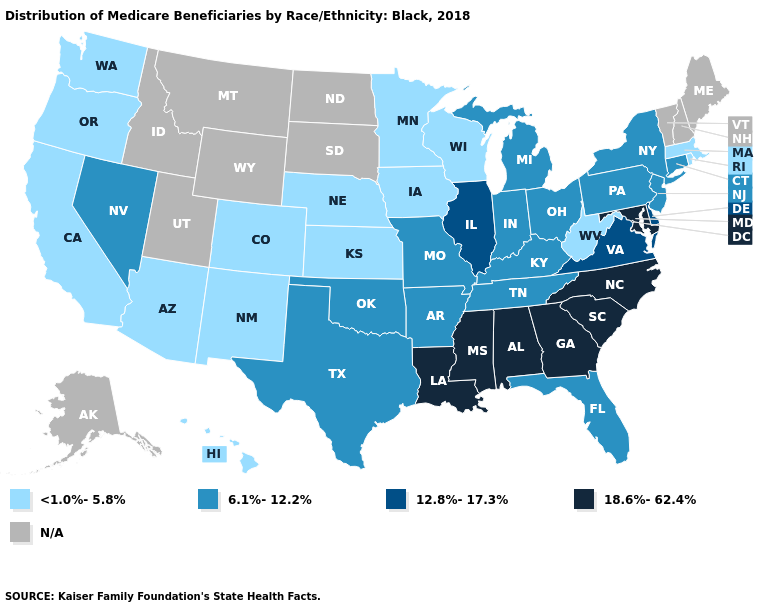Name the states that have a value in the range 6.1%-12.2%?
Keep it brief. Arkansas, Connecticut, Florida, Indiana, Kentucky, Michigan, Missouri, Nevada, New Jersey, New York, Ohio, Oklahoma, Pennsylvania, Tennessee, Texas. What is the value of Colorado?
Be succinct. <1.0%-5.8%. Name the states that have a value in the range N/A?
Answer briefly. Alaska, Idaho, Maine, Montana, New Hampshire, North Dakota, South Dakota, Utah, Vermont, Wyoming. Name the states that have a value in the range 6.1%-12.2%?
Quick response, please. Arkansas, Connecticut, Florida, Indiana, Kentucky, Michigan, Missouri, Nevada, New Jersey, New York, Ohio, Oklahoma, Pennsylvania, Tennessee, Texas. Which states hav the highest value in the MidWest?
Concise answer only. Illinois. Which states have the lowest value in the South?
Concise answer only. West Virginia. Which states have the highest value in the USA?
Short answer required. Alabama, Georgia, Louisiana, Maryland, Mississippi, North Carolina, South Carolina. How many symbols are there in the legend?
Keep it brief. 5. What is the value of Missouri?
Answer briefly. 6.1%-12.2%. Among the states that border Idaho , which have the lowest value?
Give a very brief answer. Oregon, Washington. What is the value of Idaho?
Be succinct. N/A. What is the value of Pennsylvania?
Answer briefly. 6.1%-12.2%. Does Pennsylvania have the lowest value in the Northeast?
Short answer required. No. What is the value of Hawaii?
Be succinct. <1.0%-5.8%. 